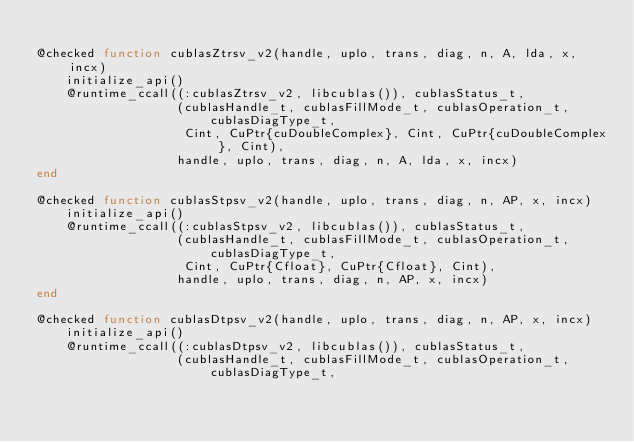Convert code to text. <code><loc_0><loc_0><loc_500><loc_500><_Julia_>
@checked function cublasZtrsv_v2(handle, uplo, trans, diag, n, A, lda, x, incx)
    initialize_api()
    @runtime_ccall((:cublasZtrsv_v2, libcublas()), cublasStatus_t,
                   (cublasHandle_t, cublasFillMode_t, cublasOperation_t, cublasDiagType_t,
                    Cint, CuPtr{cuDoubleComplex}, Cint, CuPtr{cuDoubleComplex}, Cint),
                   handle, uplo, trans, diag, n, A, lda, x, incx)
end

@checked function cublasStpsv_v2(handle, uplo, trans, diag, n, AP, x, incx)
    initialize_api()
    @runtime_ccall((:cublasStpsv_v2, libcublas()), cublasStatus_t,
                   (cublasHandle_t, cublasFillMode_t, cublasOperation_t, cublasDiagType_t,
                    Cint, CuPtr{Cfloat}, CuPtr{Cfloat}, Cint),
                   handle, uplo, trans, diag, n, AP, x, incx)
end

@checked function cublasDtpsv_v2(handle, uplo, trans, diag, n, AP, x, incx)
    initialize_api()
    @runtime_ccall((:cublasDtpsv_v2, libcublas()), cublasStatus_t,
                   (cublasHandle_t, cublasFillMode_t, cublasOperation_t, cublasDiagType_t,</code> 